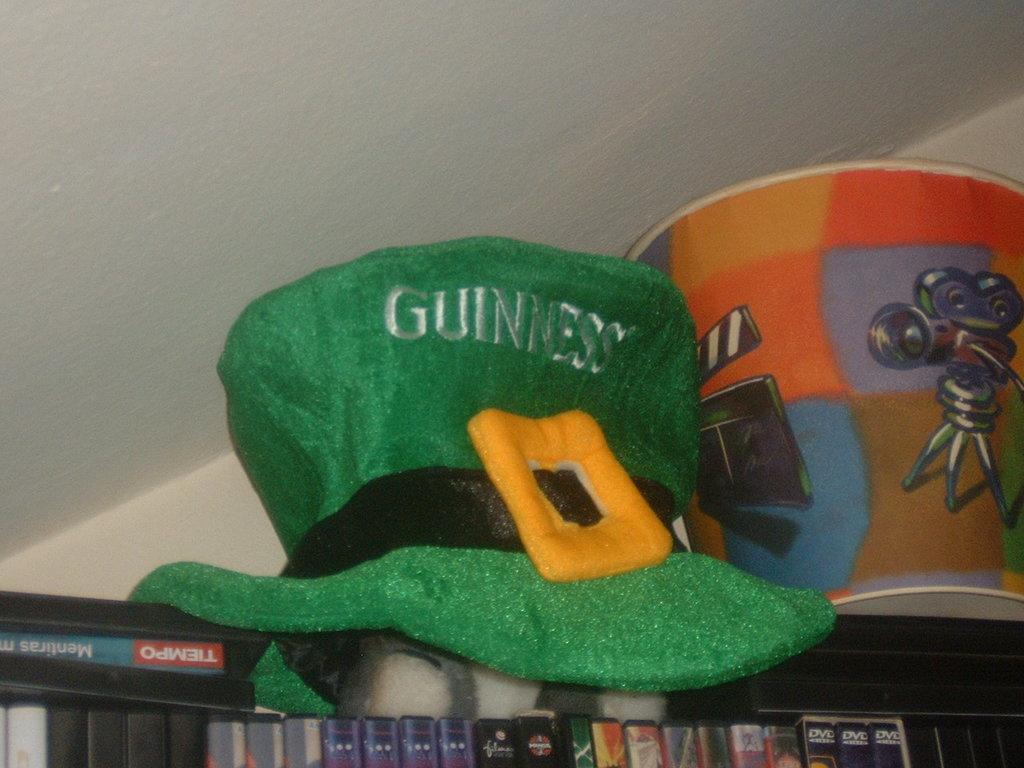Please provide a concise description of this image. This images taken Indus in the background there is a wall the bottom of the image there are many objects in the middle of the match there is a hat on the right side of the image there is a bucket 